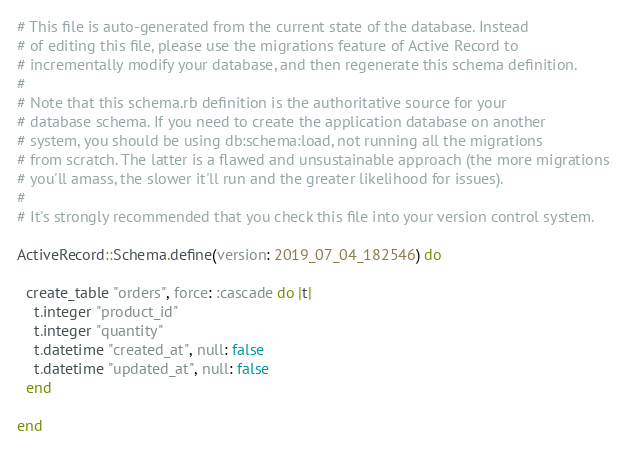<code> <loc_0><loc_0><loc_500><loc_500><_Ruby_># This file is auto-generated from the current state of the database. Instead
# of editing this file, please use the migrations feature of Active Record to
# incrementally modify your database, and then regenerate this schema definition.
#
# Note that this schema.rb definition is the authoritative source for your
# database schema. If you need to create the application database on another
# system, you should be using db:schema:load, not running all the migrations
# from scratch. The latter is a flawed and unsustainable approach (the more migrations
# you'll amass, the slower it'll run and the greater likelihood for issues).
#
# It's strongly recommended that you check this file into your version control system.

ActiveRecord::Schema.define(version: 2019_07_04_182546) do

  create_table "orders", force: :cascade do |t|
    t.integer "product_id"
    t.integer "quantity"
    t.datetime "created_at", null: false
    t.datetime "updated_at", null: false
  end

end
</code> 